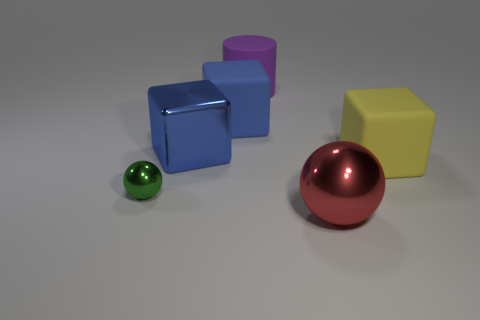Add 3 tiny yellow shiny cylinders. How many objects exist? 9 Subtract all balls. How many objects are left? 4 Add 6 green spheres. How many green spheres are left? 7 Add 2 big blue cubes. How many big blue cubes exist? 4 Subtract 0 green cylinders. How many objects are left? 6 Subtract all blue metallic things. Subtract all large blue blocks. How many objects are left? 3 